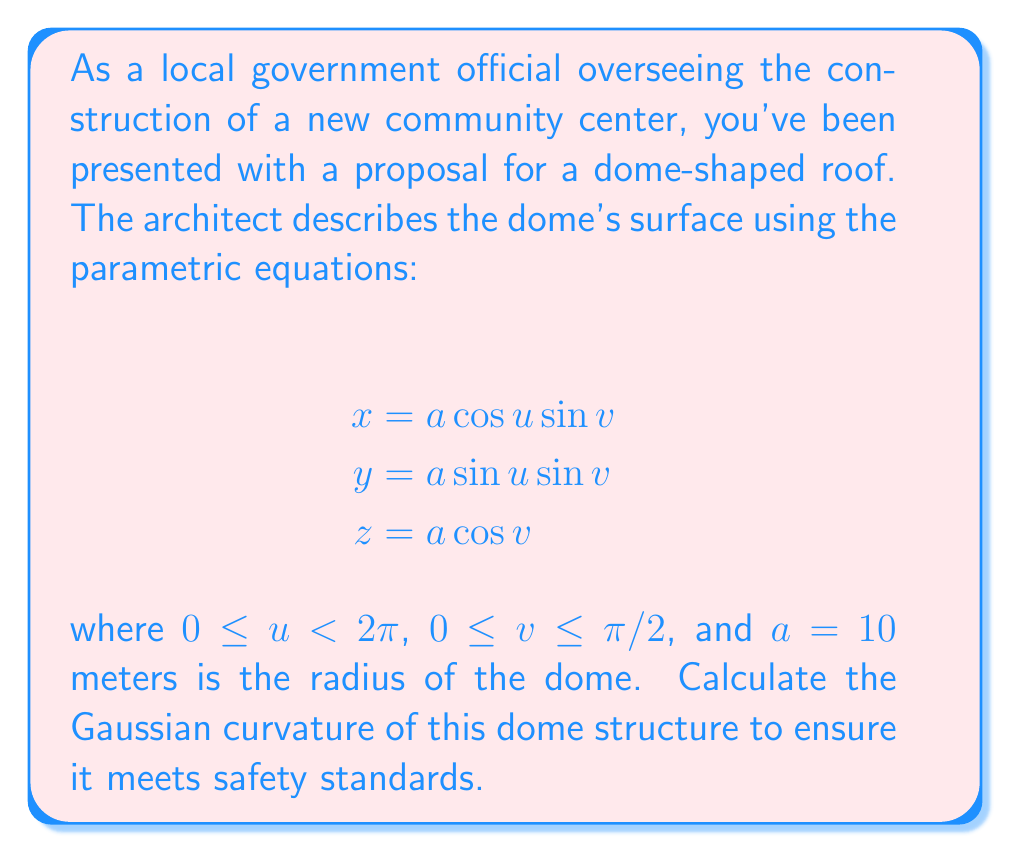Can you answer this question? To compute the Gaussian curvature, we'll follow these steps:

1) First, we need to find the first fundamental form coefficients E, F, and G:

   $\mathbf{r}_u = (-a \sin u \sin v, a \cos u \sin v, 0)$
   $\mathbf{r}_v = (a \cos u \cos v, a \sin u \cos v, -a \sin v)$

   $E = \mathbf{r}_u \cdot \mathbf{r}_u = a^2 \sin^2 v$
   $F = \mathbf{r}_u \cdot \mathbf{r}_v = 0$
   $G = \mathbf{r}_v \cdot \mathbf{r}_v = a^2$

2) Next, we calculate the second fundamental form coefficients e, f, and g:

   $\mathbf{r}_{uu} = (-a \cos u \sin v, -a \sin u \sin v, 0)$
   $\mathbf{r}_{uv} = (-a \sin u \cos v, a \cos u \cos v, 0)$
   $\mathbf{r}_{vv} = (-a \cos u \sin v, -a \sin u \sin v, -a \cos v)$

   $\mathbf{N} = \frac{\mathbf{r}_u \times \mathbf{r}_v}{|\mathbf{r}_u \times \mathbf{r}_v|} = (\cos u \sin v, \sin u \sin v, \cos v)$

   $e = \mathbf{r}_{uu} \cdot \mathbf{N} = a \sin^2 v$
   $f = \mathbf{r}_{uv} \cdot \mathbf{N} = 0$
   $g = \mathbf{r}_{vv} \cdot \mathbf{N} = a$

3) The Gaussian curvature K is given by:

   $K = \frac{eg - f^2}{EG - F^2}$

4) Substituting the values:

   $K = \frac{(a \sin^2 v)(a) - 0^2}{(a^2 \sin^2 v)(a^2) - 0^2} = \frac{a^2 \sin^2 v}{a^4 \sin^2 v} = \frac{1}{a^2}$

5) Since $a = 10$ meters:

   $K = \frac{1}{10^2} = \frac{1}{100} = 0.01 \text{ m}^{-2}$

Thus, the Gaussian curvature of the dome is constant and equal to $0.01 \text{ m}^{-2}$.
Answer: $K = 0.01 \text{ m}^{-2}$ 